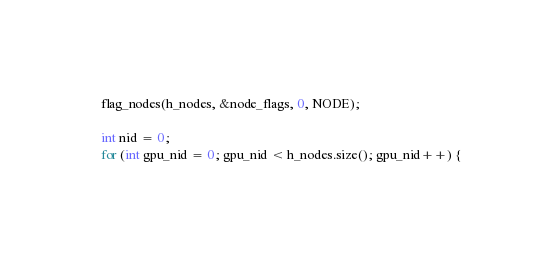<code> <loc_0><loc_0><loc_500><loc_500><_Cuda_>  flag_nodes(h_nodes, &node_flags, 0, NODE);

  int nid = 0;
  for (int gpu_nid = 0; gpu_nid < h_nodes.size(); gpu_nid++) {</code> 